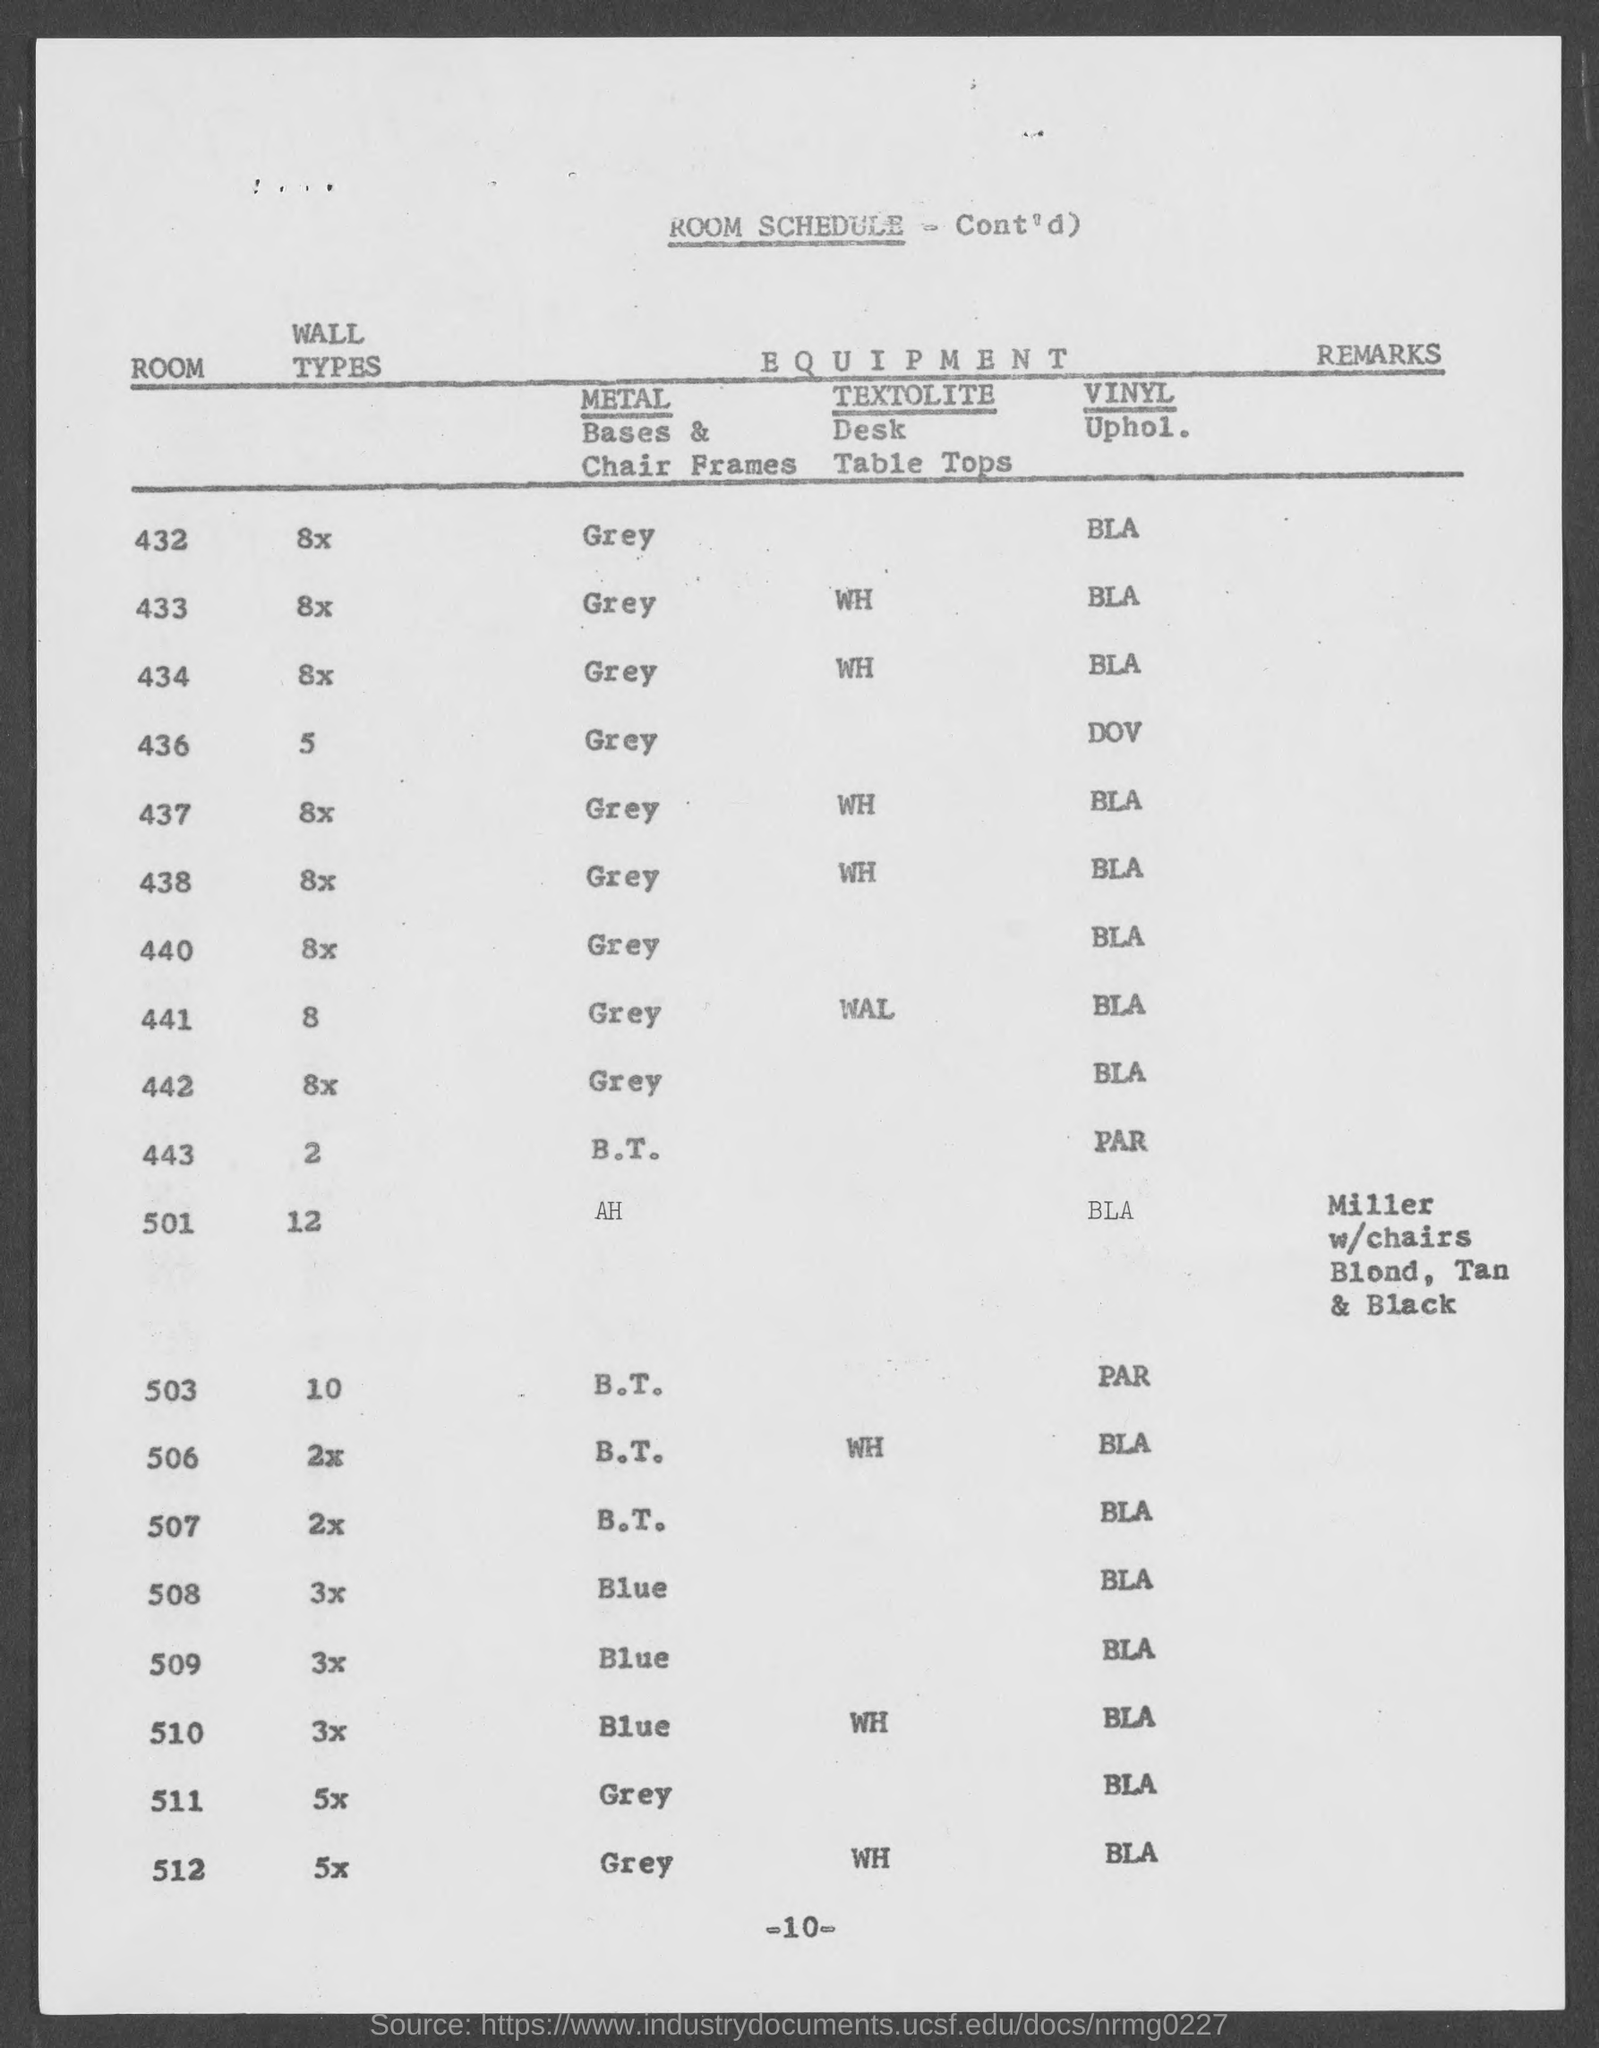What schedule is given in this document?
Make the answer very short. ROOM SCHEDULE. Which Metal Bases & Chair Frames are used for the Room 432?
Your answer should be very brief. Grey. What is the wall type used for the Room 433 as per the room schedule?
Your answer should be compact. 8x. What is the wall type used for the Room 501 as per the room schedule?
Make the answer very short. 12. What is the wall type used for the Room 508 as per the room schedule?
Ensure brevity in your answer.  3x. 